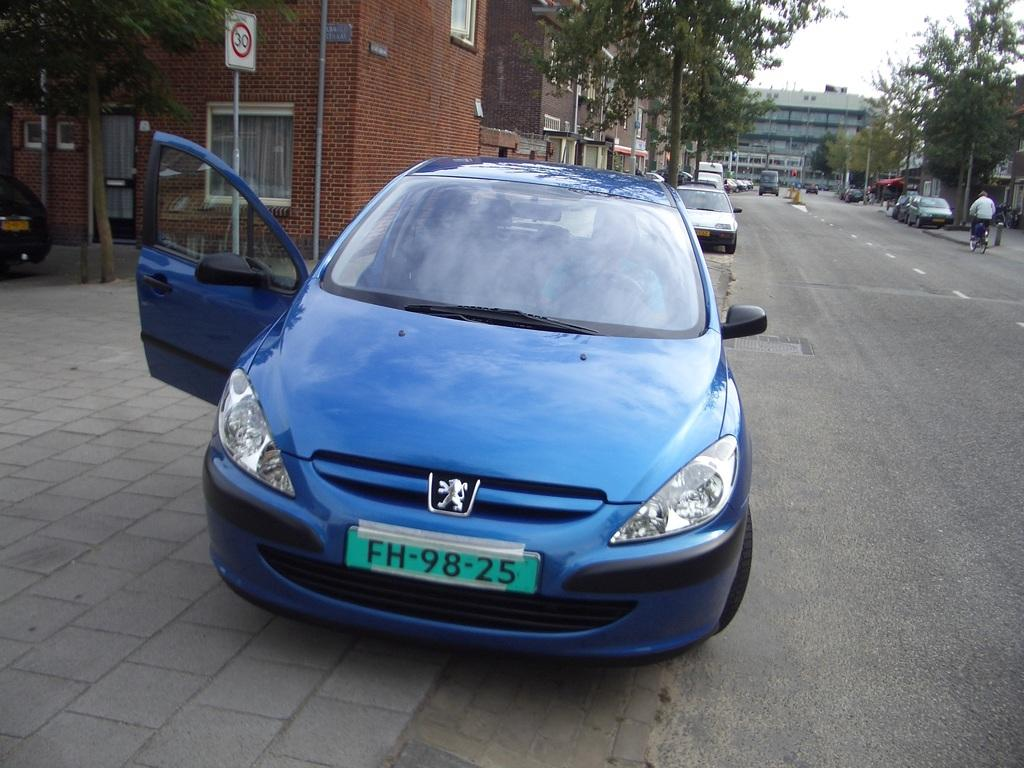Provide a one-sentence caption for the provided image. the number 98 is on the license plate of a car. 